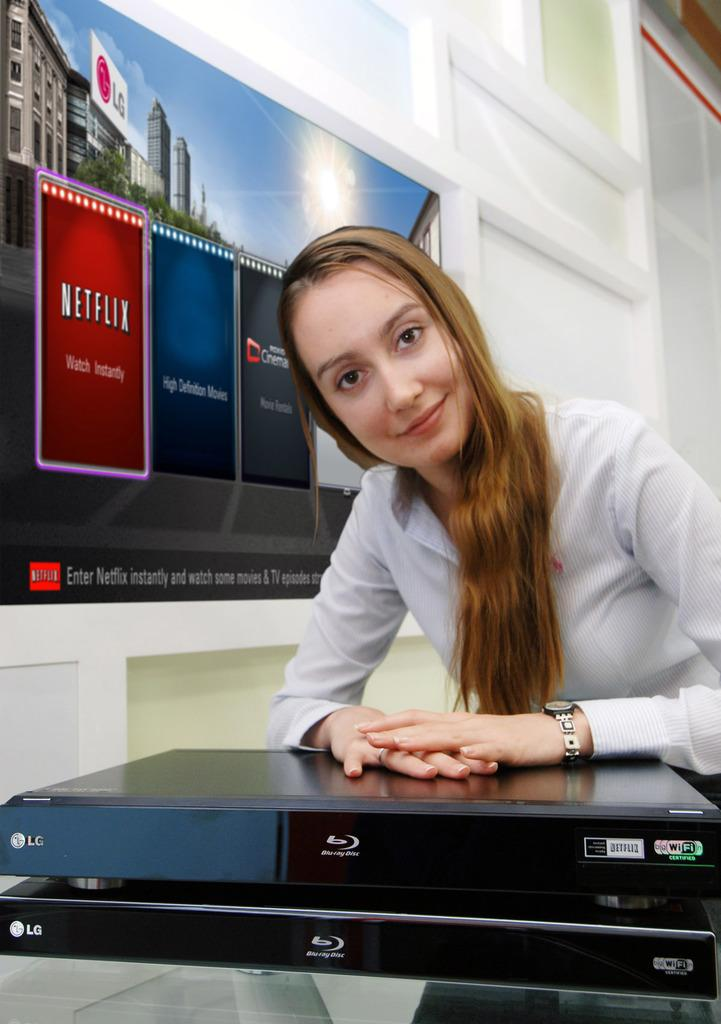Who is present in the image? There is a woman in the image. What is the woman's expression? The woman is smiling. What is the woman interacting with in the image? There is a device in front of the woman. What can be seen in the background of the image? There is a wall and a screen in the background of the image. Where is the hen standing in the image? There is no hen present in the image. What type of shade is covering the woman in the image? There is no shade present in the image; the woman is not covered by any shade. 